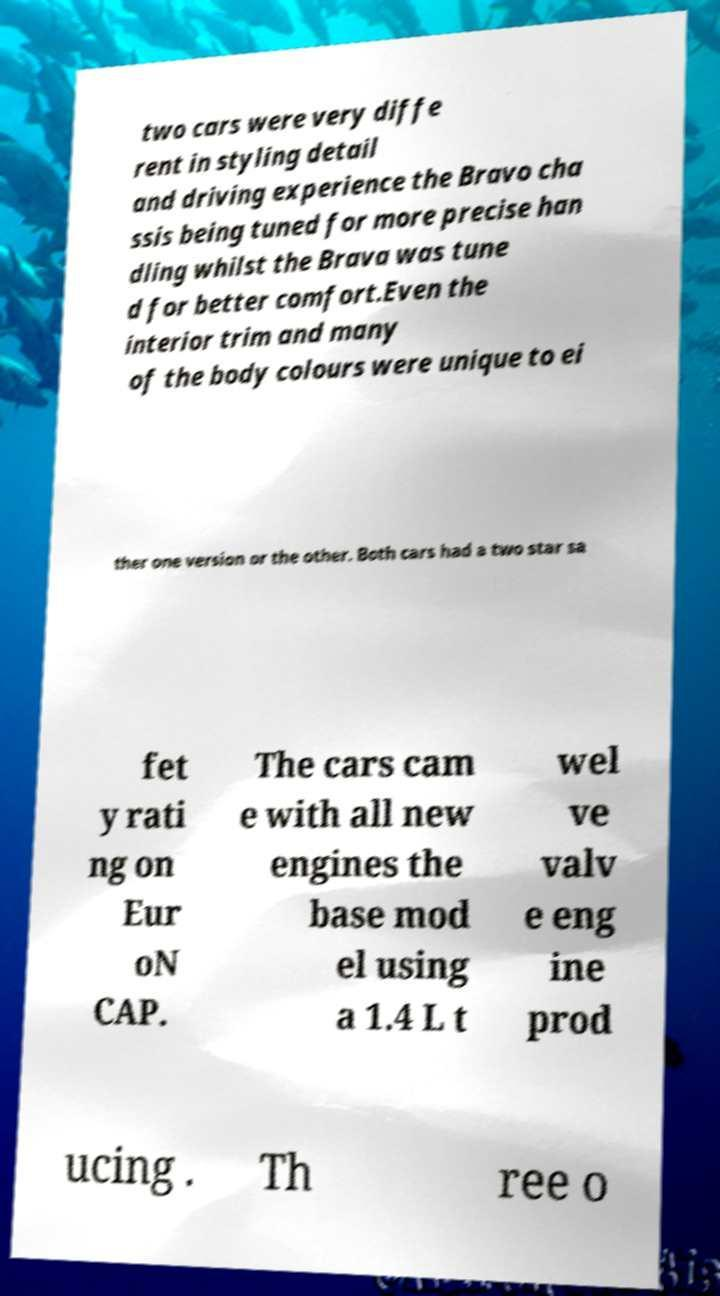What messages or text are displayed in this image? I need them in a readable, typed format. two cars were very diffe rent in styling detail and driving experience the Bravo cha ssis being tuned for more precise han dling whilst the Brava was tune d for better comfort.Even the interior trim and many of the body colours were unique to ei ther one version or the other. Both cars had a two star sa fet y rati ng on Eur oN CAP. The cars cam e with all new engines the base mod el using a 1.4 L t wel ve valv e eng ine prod ucing . Th ree o 